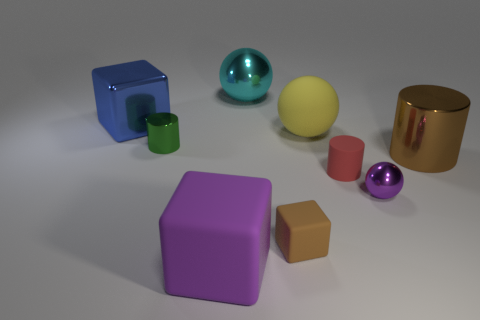Add 1 large purple blocks. How many objects exist? 10 Subtract all rubber blocks. How many blocks are left? 1 Subtract 1 blocks. How many blocks are left? 2 Subtract all spheres. How many objects are left? 6 Subtract all large yellow rubber cylinders. Subtract all cyan things. How many objects are left? 8 Add 6 big yellow rubber things. How many big yellow rubber things are left? 7 Add 8 tiny green cylinders. How many tiny green cylinders exist? 9 Subtract 1 green cylinders. How many objects are left? 8 Subtract all brown cylinders. Subtract all red spheres. How many cylinders are left? 2 Subtract all blue blocks. How many purple cylinders are left? 0 